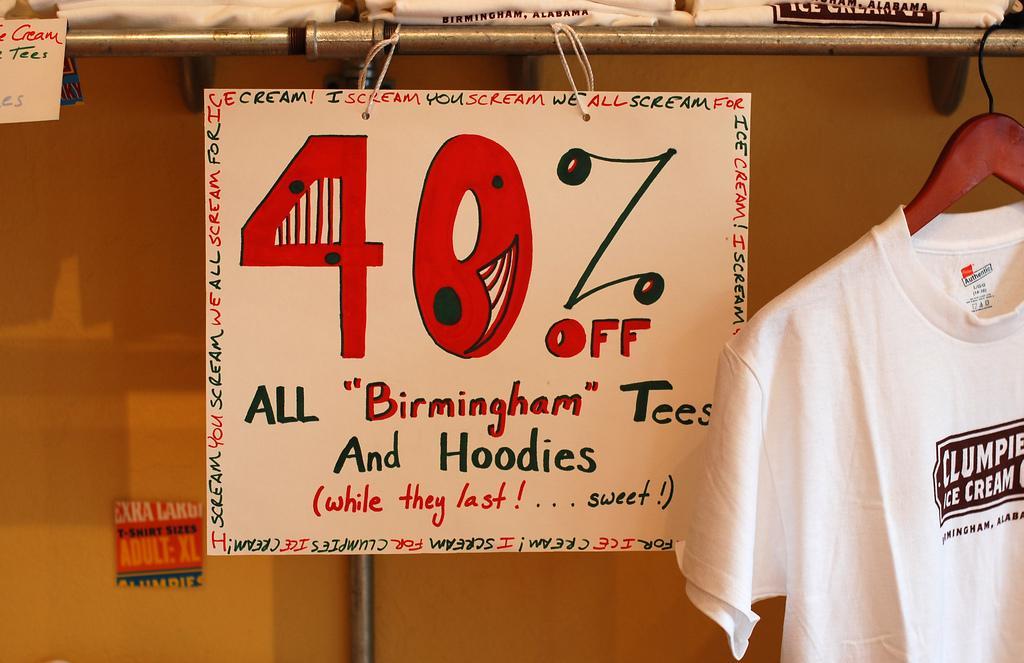In one or two sentences, can you explain what this image depicts? This picture shows few t-shirts on the shelf and we see a t-shirt to the hanger and a placard hanging to the rod. 